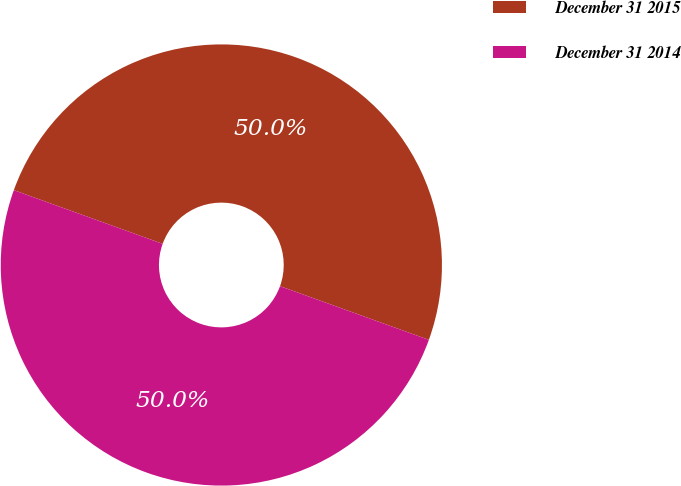<chart> <loc_0><loc_0><loc_500><loc_500><pie_chart><fcel>December 31 2015<fcel>December 31 2014<nl><fcel>50.0%<fcel>50.0%<nl></chart> 